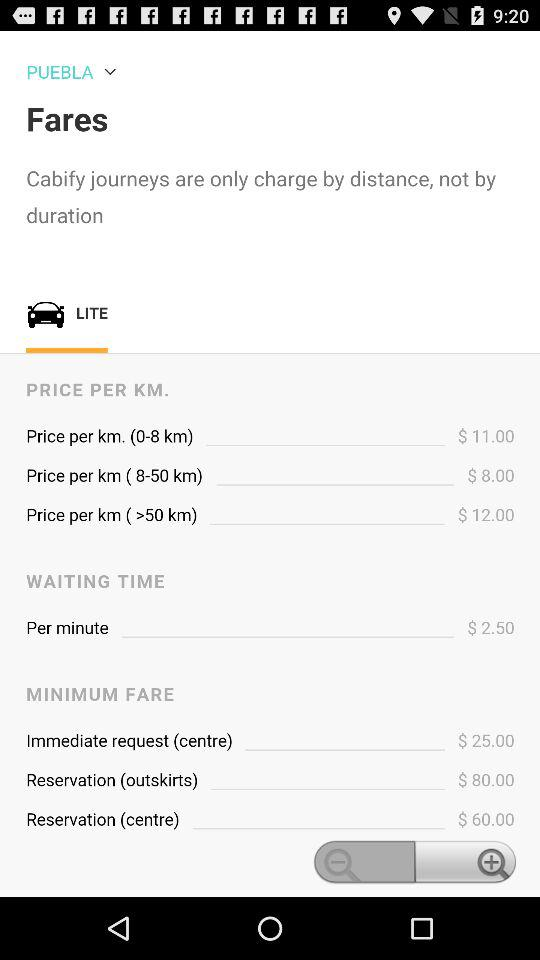What is the price per km for 0 to 8 km? The price per km for 0 to 8 km is $11. 